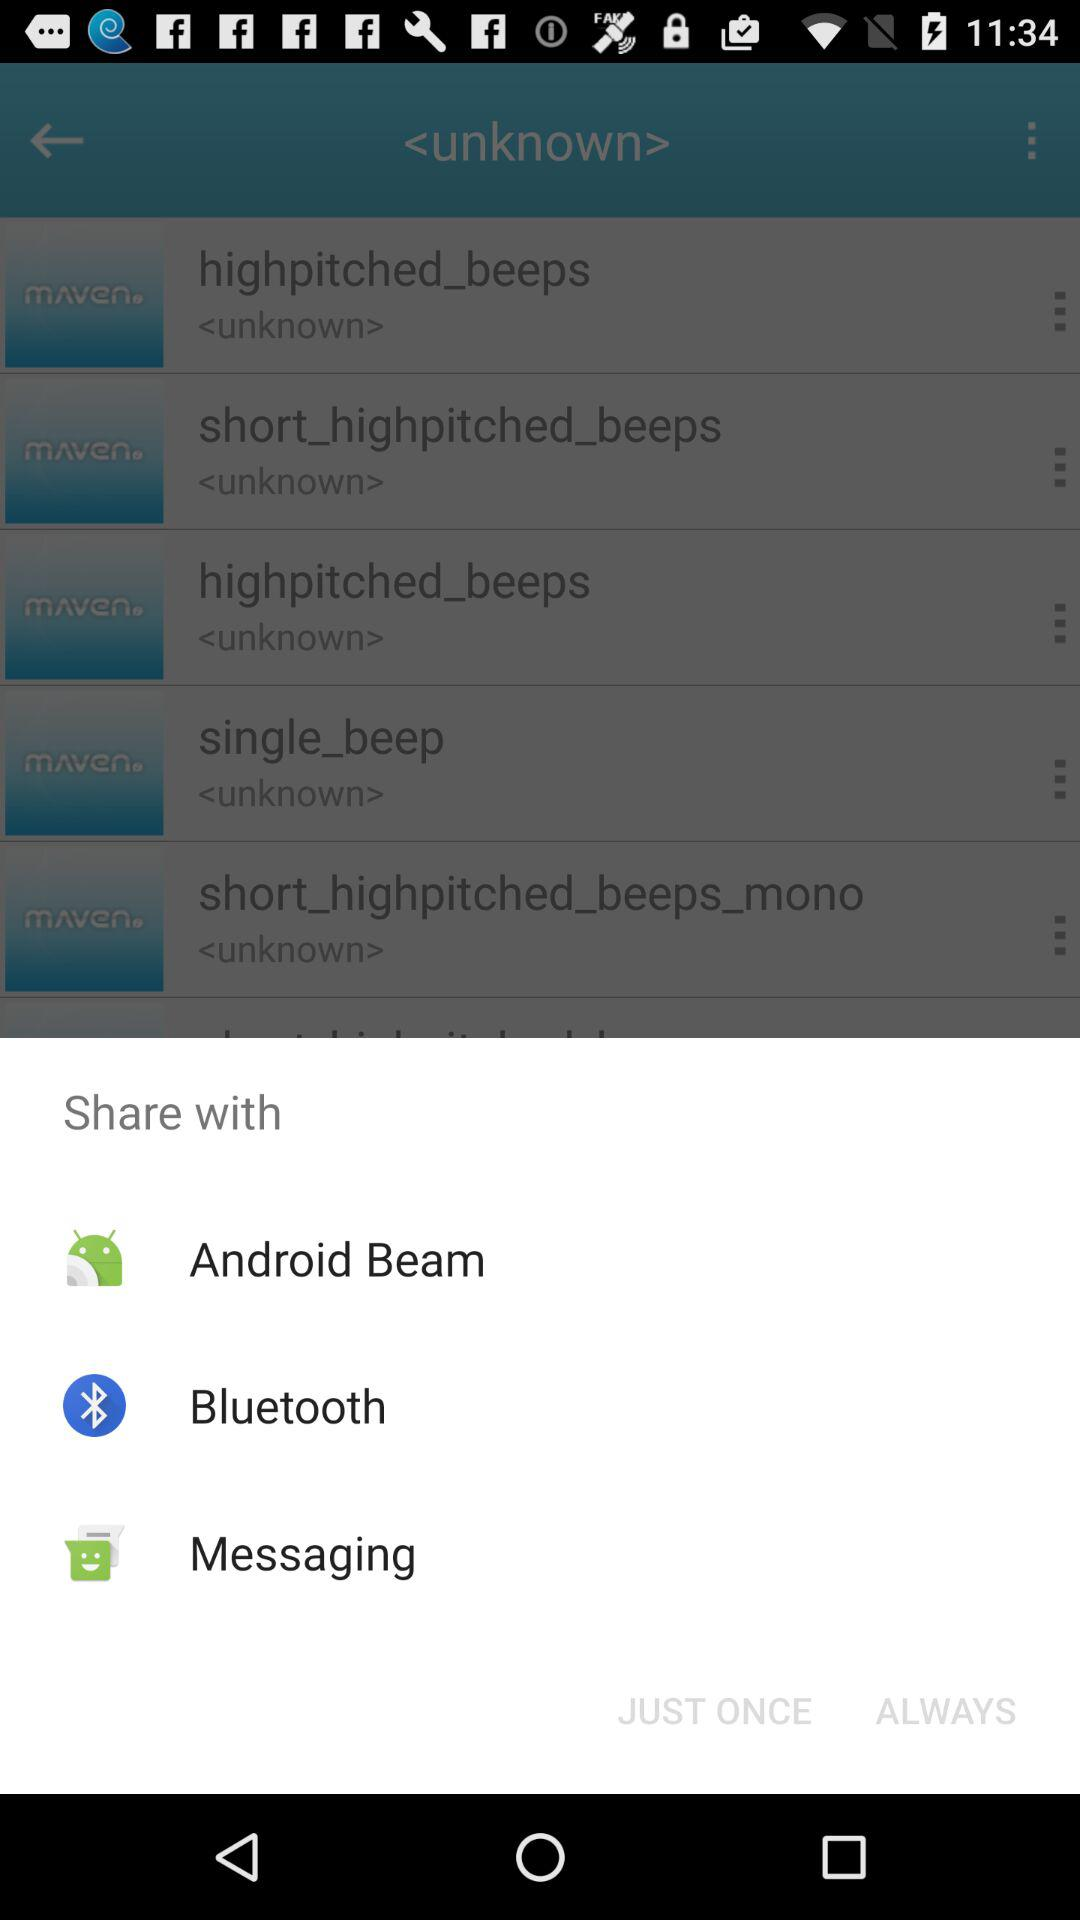Through which application can it be shared? It can be shared through "Android Beam", "Bluetooth" and "Messaging". 